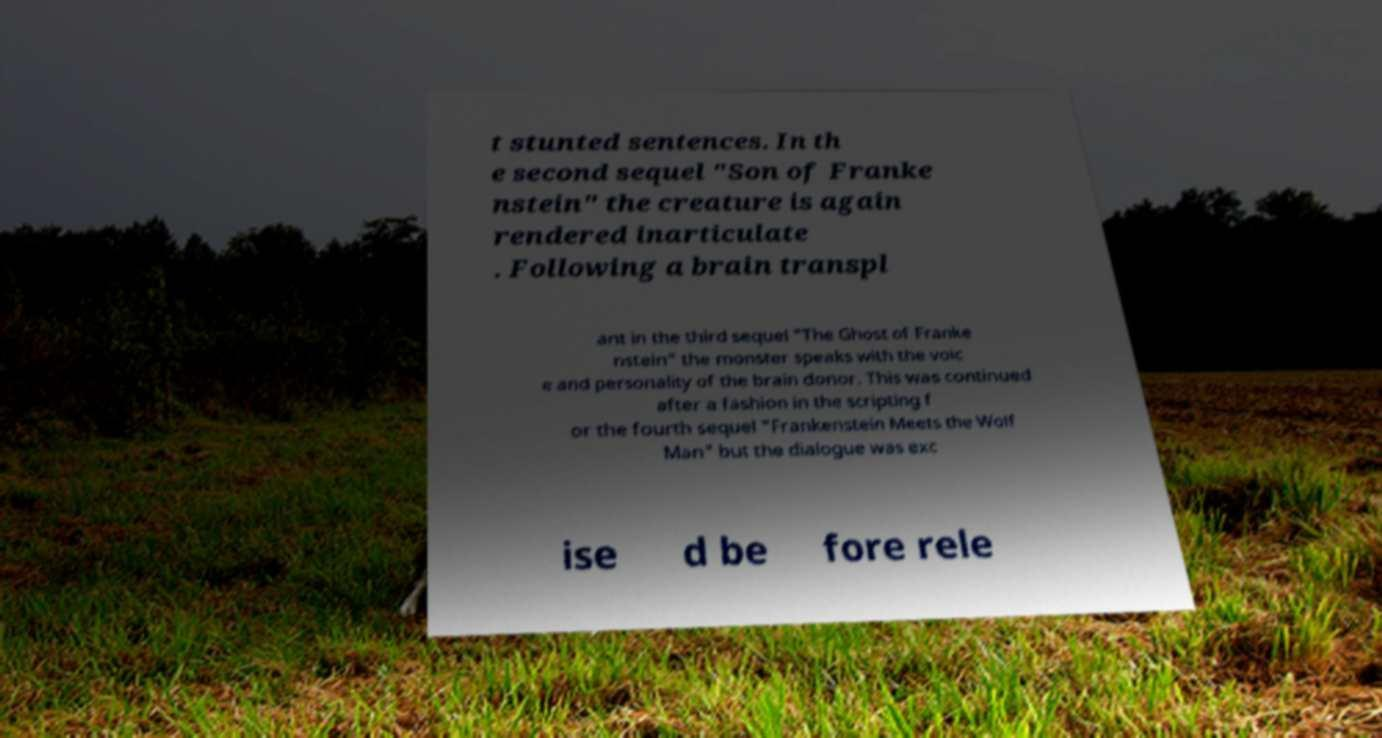Could you assist in decoding the text presented in this image and type it out clearly? t stunted sentences. In th e second sequel "Son of Franke nstein" the creature is again rendered inarticulate . Following a brain transpl ant in the third sequel "The Ghost of Franke nstein" the monster speaks with the voic e and personality of the brain donor. This was continued after a fashion in the scripting f or the fourth sequel "Frankenstein Meets the Wolf Man" but the dialogue was exc ise d be fore rele 